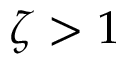<formula> <loc_0><loc_0><loc_500><loc_500>\zeta > 1</formula> 